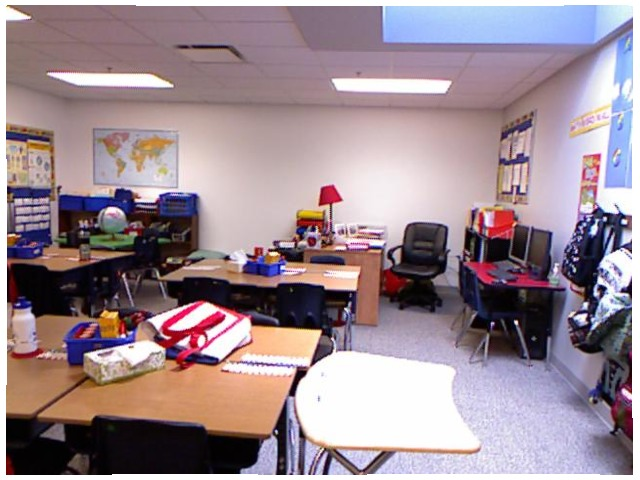<image>
Is the chair above the table? No. The chair is not positioned above the table. The vertical arrangement shows a different relationship. Is there a chair on the wall? No. The chair is not positioned on the wall. They may be near each other, but the chair is not supported by or resting on top of the wall. Where is the table in relation to the bag? Is it on the bag? No. The table is not positioned on the bag. They may be near each other, but the table is not supported by or resting on top of the bag. Is there a map behind the globe? Yes. From this viewpoint, the map is positioned behind the globe, with the globe partially or fully occluding the map. 